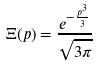<formula> <loc_0><loc_0><loc_500><loc_500>\Xi ( p ) = \frac { e ^ { - \frac { p ^ { 3 } } { 3 } } } { \sqrt { 3 \pi } }</formula> 